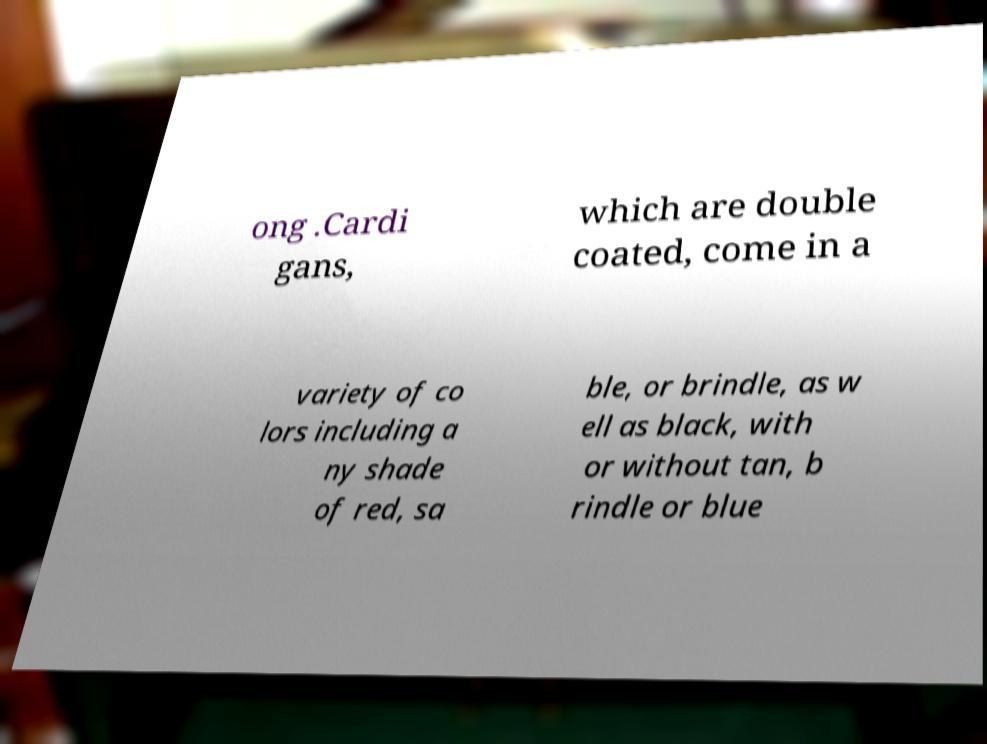There's text embedded in this image that I need extracted. Can you transcribe it verbatim? ong .Cardi gans, which are double coated, come in a variety of co lors including a ny shade of red, sa ble, or brindle, as w ell as black, with or without tan, b rindle or blue 